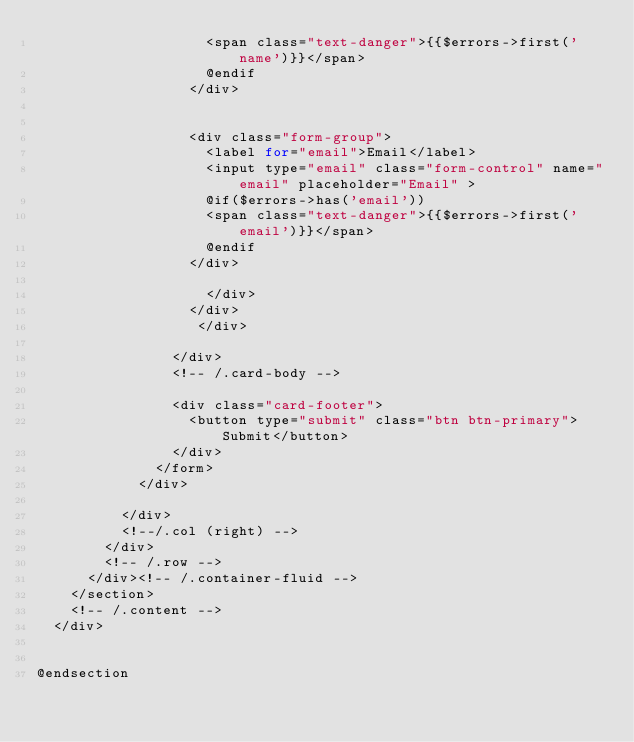<code> <loc_0><loc_0><loc_500><loc_500><_PHP_>                    <span class="text-danger">{{$errors->first('name')}}</span>
                    @endif
                  </div>


                  <div class="form-group">
                    <label for="email">Email</label>
                    <input type="email" class="form-control" name="email" placeholder="Email" >
                    @if($errors->has('email'))
                    <span class="text-danger">{{$errors->first('email')}}</span>
                    @endif
                  </div>

                    </div>
                  </div>
                   </div>

                </div>
                <!-- /.card-body -->

                <div class="card-footer">
                  <button type="submit" class="btn btn-primary">Submit</button>
                </div>
              </form>
            </div>

          </div>
          <!--/.col (right) -->
        </div>
        <!-- /.row -->
      </div><!-- /.container-fluid -->
    </section>
    <!-- /.content -->
  </div>


@endsection
</code> 